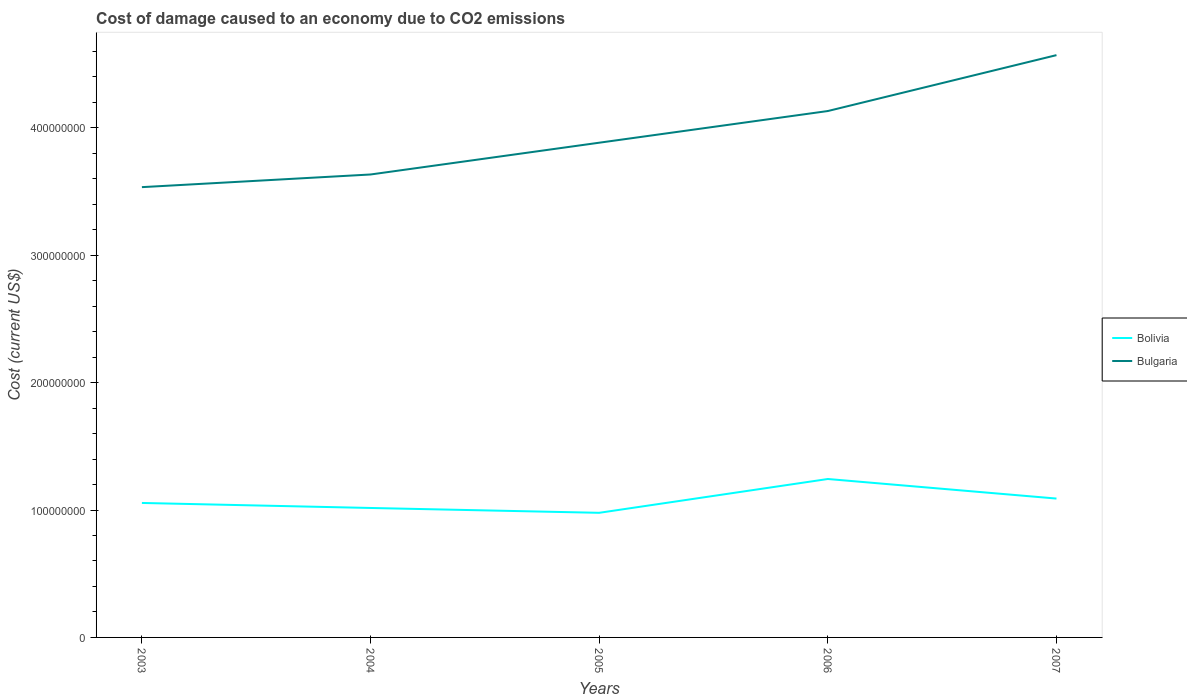How many different coloured lines are there?
Your response must be concise. 2. Across all years, what is the maximum cost of damage caused due to CO2 emissisons in Bolivia?
Provide a short and direct response. 9.78e+07. What is the total cost of damage caused due to CO2 emissisons in Bolivia in the graph?
Ensure brevity in your answer.  -3.44e+06. What is the difference between the highest and the second highest cost of damage caused due to CO2 emissisons in Bolivia?
Keep it short and to the point. 2.65e+07. What is the difference between the highest and the lowest cost of damage caused due to CO2 emissisons in Bolivia?
Keep it short and to the point. 2. How many lines are there?
Give a very brief answer. 2. How many years are there in the graph?
Your answer should be very brief. 5. What is the difference between two consecutive major ticks on the Y-axis?
Your answer should be very brief. 1.00e+08. Does the graph contain any zero values?
Your response must be concise. No. What is the title of the graph?
Your response must be concise. Cost of damage caused to an economy due to CO2 emissions. What is the label or title of the Y-axis?
Keep it short and to the point. Cost (current US$). What is the Cost (current US$) in Bolivia in 2003?
Your answer should be compact. 1.06e+08. What is the Cost (current US$) of Bulgaria in 2003?
Your response must be concise. 3.53e+08. What is the Cost (current US$) of Bolivia in 2004?
Keep it short and to the point. 1.02e+08. What is the Cost (current US$) in Bulgaria in 2004?
Your answer should be compact. 3.63e+08. What is the Cost (current US$) of Bolivia in 2005?
Provide a short and direct response. 9.78e+07. What is the Cost (current US$) of Bulgaria in 2005?
Your answer should be compact. 3.88e+08. What is the Cost (current US$) of Bolivia in 2006?
Your answer should be very brief. 1.24e+08. What is the Cost (current US$) of Bulgaria in 2006?
Offer a terse response. 4.13e+08. What is the Cost (current US$) in Bolivia in 2007?
Keep it short and to the point. 1.09e+08. What is the Cost (current US$) in Bulgaria in 2007?
Your answer should be very brief. 4.57e+08. Across all years, what is the maximum Cost (current US$) in Bolivia?
Make the answer very short. 1.24e+08. Across all years, what is the maximum Cost (current US$) of Bulgaria?
Your response must be concise. 4.57e+08. Across all years, what is the minimum Cost (current US$) in Bolivia?
Keep it short and to the point. 9.78e+07. Across all years, what is the minimum Cost (current US$) in Bulgaria?
Offer a very short reply. 3.53e+08. What is the total Cost (current US$) of Bolivia in the graph?
Give a very brief answer. 5.38e+08. What is the total Cost (current US$) of Bulgaria in the graph?
Give a very brief answer. 1.98e+09. What is the difference between the Cost (current US$) in Bolivia in 2003 and that in 2004?
Your answer should be compact. 3.94e+06. What is the difference between the Cost (current US$) in Bulgaria in 2003 and that in 2004?
Provide a short and direct response. -9.94e+06. What is the difference between the Cost (current US$) in Bolivia in 2003 and that in 2005?
Your response must be concise. 7.74e+06. What is the difference between the Cost (current US$) in Bulgaria in 2003 and that in 2005?
Your answer should be very brief. -3.49e+07. What is the difference between the Cost (current US$) of Bolivia in 2003 and that in 2006?
Provide a succinct answer. -1.88e+07. What is the difference between the Cost (current US$) of Bulgaria in 2003 and that in 2006?
Your response must be concise. -5.97e+07. What is the difference between the Cost (current US$) in Bolivia in 2003 and that in 2007?
Give a very brief answer. -3.44e+06. What is the difference between the Cost (current US$) in Bulgaria in 2003 and that in 2007?
Make the answer very short. -1.04e+08. What is the difference between the Cost (current US$) in Bolivia in 2004 and that in 2005?
Offer a very short reply. 3.80e+06. What is the difference between the Cost (current US$) in Bulgaria in 2004 and that in 2005?
Offer a terse response. -2.49e+07. What is the difference between the Cost (current US$) of Bolivia in 2004 and that in 2006?
Your answer should be very brief. -2.27e+07. What is the difference between the Cost (current US$) in Bulgaria in 2004 and that in 2006?
Offer a very short reply. -4.98e+07. What is the difference between the Cost (current US$) in Bolivia in 2004 and that in 2007?
Ensure brevity in your answer.  -7.38e+06. What is the difference between the Cost (current US$) in Bulgaria in 2004 and that in 2007?
Give a very brief answer. -9.37e+07. What is the difference between the Cost (current US$) in Bolivia in 2005 and that in 2006?
Ensure brevity in your answer.  -2.65e+07. What is the difference between the Cost (current US$) in Bulgaria in 2005 and that in 2006?
Offer a terse response. -2.49e+07. What is the difference between the Cost (current US$) in Bolivia in 2005 and that in 2007?
Provide a short and direct response. -1.12e+07. What is the difference between the Cost (current US$) of Bulgaria in 2005 and that in 2007?
Offer a terse response. -6.87e+07. What is the difference between the Cost (current US$) in Bolivia in 2006 and that in 2007?
Give a very brief answer. 1.54e+07. What is the difference between the Cost (current US$) of Bulgaria in 2006 and that in 2007?
Provide a short and direct response. -4.39e+07. What is the difference between the Cost (current US$) in Bolivia in 2003 and the Cost (current US$) in Bulgaria in 2004?
Your answer should be very brief. -2.58e+08. What is the difference between the Cost (current US$) in Bolivia in 2003 and the Cost (current US$) in Bulgaria in 2005?
Your answer should be compact. -2.83e+08. What is the difference between the Cost (current US$) of Bolivia in 2003 and the Cost (current US$) of Bulgaria in 2006?
Give a very brief answer. -3.08e+08. What is the difference between the Cost (current US$) of Bolivia in 2003 and the Cost (current US$) of Bulgaria in 2007?
Keep it short and to the point. -3.52e+08. What is the difference between the Cost (current US$) of Bolivia in 2004 and the Cost (current US$) of Bulgaria in 2005?
Offer a terse response. -2.87e+08. What is the difference between the Cost (current US$) in Bolivia in 2004 and the Cost (current US$) in Bulgaria in 2006?
Your response must be concise. -3.12e+08. What is the difference between the Cost (current US$) of Bolivia in 2004 and the Cost (current US$) of Bulgaria in 2007?
Give a very brief answer. -3.55e+08. What is the difference between the Cost (current US$) in Bolivia in 2005 and the Cost (current US$) in Bulgaria in 2006?
Your answer should be compact. -3.15e+08. What is the difference between the Cost (current US$) of Bolivia in 2005 and the Cost (current US$) of Bulgaria in 2007?
Provide a short and direct response. -3.59e+08. What is the difference between the Cost (current US$) of Bolivia in 2006 and the Cost (current US$) of Bulgaria in 2007?
Your answer should be very brief. -3.33e+08. What is the average Cost (current US$) of Bolivia per year?
Ensure brevity in your answer.  1.08e+08. What is the average Cost (current US$) in Bulgaria per year?
Make the answer very short. 3.95e+08. In the year 2003, what is the difference between the Cost (current US$) in Bolivia and Cost (current US$) in Bulgaria?
Offer a very short reply. -2.48e+08. In the year 2004, what is the difference between the Cost (current US$) of Bolivia and Cost (current US$) of Bulgaria?
Ensure brevity in your answer.  -2.62e+08. In the year 2005, what is the difference between the Cost (current US$) in Bolivia and Cost (current US$) in Bulgaria?
Offer a very short reply. -2.91e+08. In the year 2006, what is the difference between the Cost (current US$) of Bolivia and Cost (current US$) of Bulgaria?
Provide a succinct answer. -2.89e+08. In the year 2007, what is the difference between the Cost (current US$) in Bolivia and Cost (current US$) in Bulgaria?
Provide a short and direct response. -3.48e+08. What is the ratio of the Cost (current US$) in Bolivia in 2003 to that in 2004?
Make the answer very short. 1.04. What is the ratio of the Cost (current US$) of Bulgaria in 2003 to that in 2004?
Give a very brief answer. 0.97. What is the ratio of the Cost (current US$) in Bolivia in 2003 to that in 2005?
Provide a succinct answer. 1.08. What is the ratio of the Cost (current US$) in Bulgaria in 2003 to that in 2005?
Offer a very short reply. 0.91. What is the ratio of the Cost (current US$) in Bolivia in 2003 to that in 2006?
Provide a short and direct response. 0.85. What is the ratio of the Cost (current US$) in Bulgaria in 2003 to that in 2006?
Give a very brief answer. 0.86. What is the ratio of the Cost (current US$) in Bolivia in 2003 to that in 2007?
Keep it short and to the point. 0.97. What is the ratio of the Cost (current US$) of Bulgaria in 2003 to that in 2007?
Provide a short and direct response. 0.77. What is the ratio of the Cost (current US$) in Bolivia in 2004 to that in 2005?
Your answer should be very brief. 1.04. What is the ratio of the Cost (current US$) in Bulgaria in 2004 to that in 2005?
Your response must be concise. 0.94. What is the ratio of the Cost (current US$) of Bolivia in 2004 to that in 2006?
Give a very brief answer. 0.82. What is the ratio of the Cost (current US$) in Bulgaria in 2004 to that in 2006?
Make the answer very short. 0.88. What is the ratio of the Cost (current US$) of Bolivia in 2004 to that in 2007?
Keep it short and to the point. 0.93. What is the ratio of the Cost (current US$) in Bulgaria in 2004 to that in 2007?
Make the answer very short. 0.8. What is the ratio of the Cost (current US$) in Bolivia in 2005 to that in 2006?
Provide a succinct answer. 0.79. What is the ratio of the Cost (current US$) of Bulgaria in 2005 to that in 2006?
Ensure brevity in your answer.  0.94. What is the ratio of the Cost (current US$) of Bolivia in 2005 to that in 2007?
Offer a very short reply. 0.9. What is the ratio of the Cost (current US$) in Bulgaria in 2005 to that in 2007?
Offer a very short reply. 0.85. What is the ratio of the Cost (current US$) of Bolivia in 2006 to that in 2007?
Your answer should be very brief. 1.14. What is the ratio of the Cost (current US$) of Bulgaria in 2006 to that in 2007?
Your answer should be compact. 0.9. What is the difference between the highest and the second highest Cost (current US$) of Bolivia?
Give a very brief answer. 1.54e+07. What is the difference between the highest and the second highest Cost (current US$) of Bulgaria?
Offer a terse response. 4.39e+07. What is the difference between the highest and the lowest Cost (current US$) of Bolivia?
Your response must be concise. 2.65e+07. What is the difference between the highest and the lowest Cost (current US$) in Bulgaria?
Your answer should be very brief. 1.04e+08. 